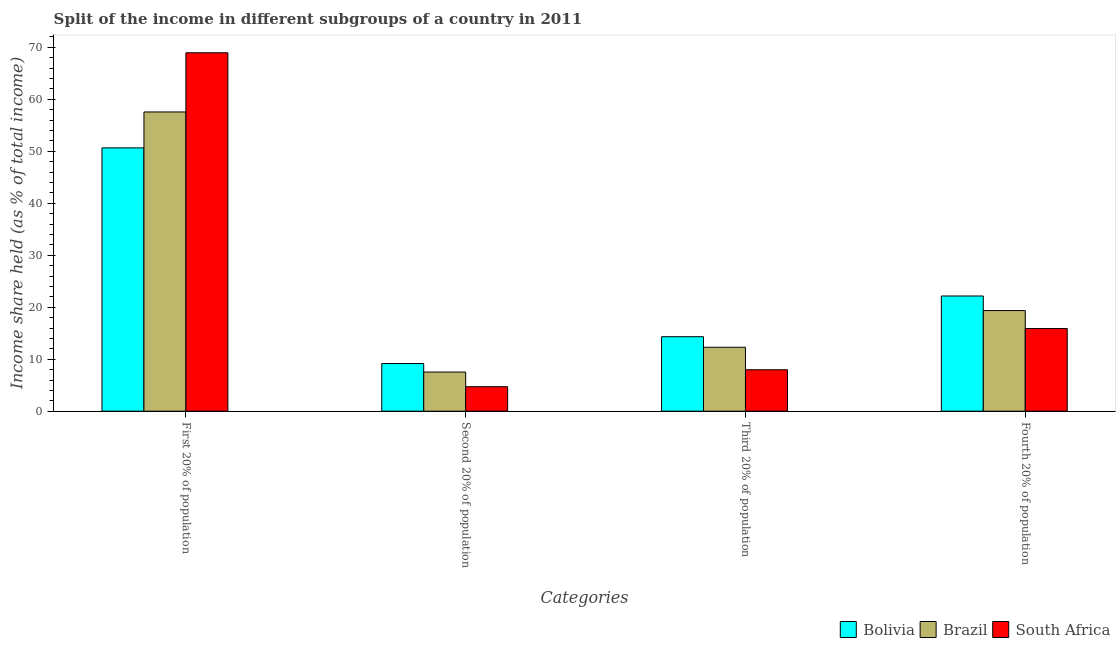How many groups of bars are there?
Offer a terse response. 4. Are the number of bars per tick equal to the number of legend labels?
Provide a short and direct response. Yes. Are the number of bars on each tick of the X-axis equal?
Your response must be concise. Yes. What is the label of the 4th group of bars from the left?
Your response must be concise. Fourth 20% of population. Across all countries, what is the maximum share of the income held by first 20% of the population?
Make the answer very short. 68.94. Across all countries, what is the minimum share of the income held by second 20% of the population?
Keep it short and to the point. 4.71. In which country was the share of the income held by third 20% of the population minimum?
Your answer should be very brief. South Africa. What is the total share of the income held by first 20% of the population in the graph?
Make the answer very short. 177.15. What is the difference between the share of the income held by third 20% of the population in Brazil and that in Bolivia?
Keep it short and to the point. -2.03. What is the difference between the share of the income held by first 20% of the population in South Africa and the share of the income held by third 20% of the population in Brazil?
Provide a short and direct response. 56.64. What is the average share of the income held by third 20% of the population per country?
Keep it short and to the point. 11.53. What is the difference between the share of the income held by first 20% of the population and share of the income held by third 20% of the population in South Africa?
Offer a terse response. 60.97. In how many countries, is the share of the income held by first 20% of the population greater than 14 %?
Provide a succinct answer. 3. What is the ratio of the share of the income held by third 20% of the population in Brazil to that in Bolivia?
Offer a terse response. 0.86. Is the difference between the share of the income held by second 20% of the population in Bolivia and South Africa greater than the difference between the share of the income held by third 20% of the population in Bolivia and South Africa?
Offer a very short reply. No. What is the difference between the highest and the second highest share of the income held by third 20% of the population?
Your response must be concise. 2.03. What is the difference between the highest and the lowest share of the income held by third 20% of the population?
Give a very brief answer. 6.36. In how many countries, is the share of the income held by first 20% of the population greater than the average share of the income held by first 20% of the population taken over all countries?
Keep it short and to the point. 1. Is the sum of the share of the income held by second 20% of the population in South Africa and Brazil greater than the maximum share of the income held by fourth 20% of the population across all countries?
Offer a very short reply. No. What does the 1st bar from the right in Fourth 20% of population represents?
Your response must be concise. South Africa. Is it the case that in every country, the sum of the share of the income held by first 20% of the population and share of the income held by second 20% of the population is greater than the share of the income held by third 20% of the population?
Provide a succinct answer. Yes. How many bars are there?
Your response must be concise. 12. How many countries are there in the graph?
Provide a short and direct response. 3. Does the graph contain grids?
Ensure brevity in your answer.  No. How many legend labels are there?
Make the answer very short. 3. What is the title of the graph?
Your answer should be very brief. Split of the income in different subgroups of a country in 2011. Does "Malta" appear as one of the legend labels in the graph?
Make the answer very short. No. What is the label or title of the X-axis?
Make the answer very short. Categories. What is the label or title of the Y-axis?
Your answer should be compact. Income share held (as % of total income). What is the Income share held (as % of total income) of Bolivia in First 20% of population?
Your answer should be compact. 50.65. What is the Income share held (as % of total income) of Brazil in First 20% of population?
Offer a terse response. 57.56. What is the Income share held (as % of total income) in South Africa in First 20% of population?
Offer a terse response. 68.94. What is the Income share held (as % of total income) in Bolivia in Second 20% of population?
Give a very brief answer. 9.17. What is the Income share held (as % of total income) in Brazil in Second 20% of population?
Your response must be concise. 7.53. What is the Income share held (as % of total income) in South Africa in Second 20% of population?
Ensure brevity in your answer.  4.71. What is the Income share held (as % of total income) in Bolivia in Third 20% of population?
Provide a short and direct response. 14.33. What is the Income share held (as % of total income) of South Africa in Third 20% of population?
Keep it short and to the point. 7.97. What is the Income share held (as % of total income) in Bolivia in Fourth 20% of population?
Keep it short and to the point. 22.16. What is the Income share held (as % of total income) of Brazil in Fourth 20% of population?
Provide a short and direct response. 19.36. Across all Categories, what is the maximum Income share held (as % of total income) of Bolivia?
Provide a succinct answer. 50.65. Across all Categories, what is the maximum Income share held (as % of total income) in Brazil?
Offer a terse response. 57.56. Across all Categories, what is the maximum Income share held (as % of total income) in South Africa?
Your answer should be compact. 68.94. Across all Categories, what is the minimum Income share held (as % of total income) of Bolivia?
Keep it short and to the point. 9.17. Across all Categories, what is the minimum Income share held (as % of total income) of Brazil?
Your response must be concise. 7.53. Across all Categories, what is the minimum Income share held (as % of total income) of South Africa?
Offer a terse response. 4.71. What is the total Income share held (as % of total income) in Bolivia in the graph?
Provide a succinct answer. 96.31. What is the total Income share held (as % of total income) of Brazil in the graph?
Your answer should be very brief. 96.75. What is the total Income share held (as % of total income) in South Africa in the graph?
Offer a terse response. 97.52. What is the difference between the Income share held (as % of total income) of Bolivia in First 20% of population and that in Second 20% of population?
Give a very brief answer. 41.48. What is the difference between the Income share held (as % of total income) of Brazil in First 20% of population and that in Second 20% of population?
Your answer should be very brief. 50.03. What is the difference between the Income share held (as % of total income) of South Africa in First 20% of population and that in Second 20% of population?
Your answer should be very brief. 64.23. What is the difference between the Income share held (as % of total income) of Bolivia in First 20% of population and that in Third 20% of population?
Your response must be concise. 36.32. What is the difference between the Income share held (as % of total income) in Brazil in First 20% of population and that in Third 20% of population?
Keep it short and to the point. 45.26. What is the difference between the Income share held (as % of total income) of South Africa in First 20% of population and that in Third 20% of population?
Provide a succinct answer. 60.97. What is the difference between the Income share held (as % of total income) in Bolivia in First 20% of population and that in Fourth 20% of population?
Keep it short and to the point. 28.49. What is the difference between the Income share held (as % of total income) in Brazil in First 20% of population and that in Fourth 20% of population?
Offer a very short reply. 38.2. What is the difference between the Income share held (as % of total income) in South Africa in First 20% of population and that in Fourth 20% of population?
Provide a short and direct response. 53.04. What is the difference between the Income share held (as % of total income) in Bolivia in Second 20% of population and that in Third 20% of population?
Your answer should be compact. -5.16. What is the difference between the Income share held (as % of total income) of Brazil in Second 20% of population and that in Third 20% of population?
Give a very brief answer. -4.77. What is the difference between the Income share held (as % of total income) in South Africa in Second 20% of population and that in Third 20% of population?
Make the answer very short. -3.26. What is the difference between the Income share held (as % of total income) of Bolivia in Second 20% of population and that in Fourth 20% of population?
Provide a short and direct response. -12.99. What is the difference between the Income share held (as % of total income) in Brazil in Second 20% of population and that in Fourth 20% of population?
Provide a succinct answer. -11.83. What is the difference between the Income share held (as % of total income) in South Africa in Second 20% of population and that in Fourth 20% of population?
Give a very brief answer. -11.19. What is the difference between the Income share held (as % of total income) of Bolivia in Third 20% of population and that in Fourth 20% of population?
Ensure brevity in your answer.  -7.83. What is the difference between the Income share held (as % of total income) in Brazil in Third 20% of population and that in Fourth 20% of population?
Provide a short and direct response. -7.06. What is the difference between the Income share held (as % of total income) in South Africa in Third 20% of population and that in Fourth 20% of population?
Provide a succinct answer. -7.93. What is the difference between the Income share held (as % of total income) in Bolivia in First 20% of population and the Income share held (as % of total income) in Brazil in Second 20% of population?
Your response must be concise. 43.12. What is the difference between the Income share held (as % of total income) of Bolivia in First 20% of population and the Income share held (as % of total income) of South Africa in Second 20% of population?
Your answer should be compact. 45.94. What is the difference between the Income share held (as % of total income) of Brazil in First 20% of population and the Income share held (as % of total income) of South Africa in Second 20% of population?
Provide a succinct answer. 52.85. What is the difference between the Income share held (as % of total income) of Bolivia in First 20% of population and the Income share held (as % of total income) of Brazil in Third 20% of population?
Give a very brief answer. 38.35. What is the difference between the Income share held (as % of total income) in Bolivia in First 20% of population and the Income share held (as % of total income) in South Africa in Third 20% of population?
Provide a short and direct response. 42.68. What is the difference between the Income share held (as % of total income) of Brazil in First 20% of population and the Income share held (as % of total income) of South Africa in Third 20% of population?
Offer a very short reply. 49.59. What is the difference between the Income share held (as % of total income) of Bolivia in First 20% of population and the Income share held (as % of total income) of Brazil in Fourth 20% of population?
Provide a short and direct response. 31.29. What is the difference between the Income share held (as % of total income) in Bolivia in First 20% of population and the Income share held (as % of total income) in South Africa in Fourth 20% of population?
Offer a terse response. 34.75. What is the difference between the Income share held (as % of total income) in Brazil in First 20% of population and the Income share held (as % of total income) in South Africa in Fourth 20% of population?
Your response must be concise. 41.66. What is the difference between the Income share held (as % of total income) of Bolivia in Second 20% of population and the Income share held (as % of total income) of Brazil in Third 20% of population?
Your answer should be very brief. -3.13. What is the difference between the Income share held (as % of total income) in Bolivia in Second 20% of population and the Income share held (as % of total income) in South Africa in Third 20% of population?
Your response must be concise. 1.2. What is the difference between the Income share held (as % of total income) in Brazil in Second 20% of population and the Income share held (as % of total income) in South Africa in Third 20% of population?
Offer a very short reply. -0.44. What is the difference between the Income share held (as % of total income) in Bolivia in Second 20% of population and the Income share held (as % of total income) in Brazil in Fourth 20% of population?
Your response must be concise. -10.19. What is the difference between the Income share held (as % of total income) in Bolivia in Second 20% of population and the Income share held (as % of total income) in South Africa in Fourth 20% of population?
Offer a terse response. -6.73. What is the difference between the Income share held (as % of total income) in Brazil in Second 20% of population and the Income share held (as % of total income) in South Africa in Fourth 20% of population?
Keep it short and to the point. -8.37. What is the difference between the Income share held (as % of total income) of Bolivia in Third 20% of population and the Income share held (as % of total income) of Brazil in Fourth 20% of population?
Make the answer very short. -5.03. What is the difference between the Income share held (as % of total income) in Bolivia in Third 20% of population and the Income share held (as % of total income) in South Africa in Fourth 20% of population?
Your answer should be very brief. -1.57. What is the difference between the Income share held (as % of total income) in Brazil in Third 20% of population and the Income share held (as % of total income) in South Africa in Fourth 20% of population?
Ensure brevity in your answer.  -3.6. What is the average Income share held (as % of total income) in Bolivia per Categories?
Your answer should be compact. 24.08. What is the average Income share held (as % of total income) of Brazil per Categories?
Offer a terse response. 24.19. What is the average Income share held (as % of total income) in South Africa per Categories?
Offer a terse response. 24.38. What is the difference between the Income share held (as % of total income) of Bolivia and Income share held (as % of total income) of Brazil in First 20% of population?
Your response must be concise. -6.91. What is the difference between the Income share held (as % of total income) of Bolivia and Income share held (as % of total income) of South Africa in First 20% of population?
Offer a terse response. -18.29. What is the difference between the Income share held (as % of total income) of Brazil and Income share held (as % of total income) of South Africa in First 20% of population?
Your response must be concise. -11.38. What is the difference between the Income share held (as % of total income) of Bolivia and Income share held (as % of total income) of Brazil in Second 20% of population?
Provide a short and direct response. 1.64. What is the difference between the Income share held (as % of total income) in Bolivia and Income share held (as % of total income) in South Africa in Second 20% of population?
Make the answer very short. 4.46. What is the difference between the Income share held (as % of total income) in Brazil and Income share held (as % of total income) in South Africa in Second 20% of population?
Provide a succinct answer. 2.82. What is the difference between the Income share held (as % of total income) in Bolivia and Income share held (as % of total income) in Brazil in Third 20% of population?
Your answer should be very brief. 2.03. What is the difference between the Income share held (as % of total income) in Bolivia and Income share held (as % of total income) in South Africa in Third 20% of population?
Ensure brevity in your answer.  6.36. What is the difference between the Income share held (as % of total income) in Brazil and Income share held (as % of total income) in South Africa in Third 20% of population?
Your answer should be very brief. 4.33. What is the difference between the Income share held (as % of total income) in Bolivia and Income share held (as % of total income) in South Africa in Fourth 20% of population?
Offer a very short reply. 6.26. What is the difference between the Income share held (as % of total income) in Brazil and Income share held (as % of total income) in South Africa in Fourth 20% of population?
Provide a short and direct response. 3.46. What is the ratio of the Income share held (as % of total income) in Bolivia in First 20% of population to that in Second 20% of population?
Keep it short and to the point. 5.52. What is the ratio of the Income share held (as % of total income) of Brazil in First 20% of population to that in Second 20% of population?
Offer a very short reply. 7.64. What is the ratio of the Income share held (as % of total income) in South Africa in First 20% of population to that in Second 20% of population?
Offer a terse response. 14.64. What is the ratio of the Income share held (as % of total income) in Bolivia in First 20% of population to that in Third 20% of population?
Your answer should be compact. 3.53. What is the ratio of the Income share held (as % of total income) in Brazil in First 20% of population to that in Third 20% of population?
Your answer should be very brief. 4.68. What is the ratio of the Income share held (as % of total income) of South Africa in First 20% of population to that in Third 20% of population?
Your answer should be very brief. 8.65. What is the ratio of the Income share held (as % of total income) of Bolivia in First 20% of population to that in Fourth 20% of population?
Your response must be concise. 2.29. What is the ratio of the Income share held (as % of total income) in Brazil in First 20% of population to that in Fourth 20% of population?
Make the answer very short. 2.97. What is the ratio of the Income share held (as % of total income) of South Africa in First 20% of population to that in Fourth 20% of population?
Give a very brief answer. 4.34. What is the ratio of the Income share held (as % of total income) of Bolivia in Second 20% of population to that in Third 20% of population?
Keep it short and to the point. 0.64. What is the ratio of the Income share held (as % of total income) of Brazil in Second 20% of population to that in Third 20% of population?
Provide a succinct answer. 0.61. What is the ratio of the Income share held (as % of total income) of South Africa in Second 20% of population to that in Third 20% of population?
Keep it short and to the point. 0.59. What is the ratio of the Income share held (as % of total income) in Bolivia in Second 20% of population to that in Fourth 20% of population?
Your answer should be compact. 0.41. What is the ratio of the Income share held (as % of total income) of Brazil in Second 20% of population to that in Fourth 20% of population?
Offer a terse response. 0.39. What is the ratio of the Income share held (as % of total income) in South Africa in Second 20% of population to that in Fourth 20% of population?
Make the answer very short. 0.3. What is the ratio of the Income share held (as % of total income) of Bolivia in Third 20% of population to that in Fourth 20% of population?
Provide a short and direct response. 0.65. What is the ratio of the Income share held (as % of total income) in Brazil in Third 20% of population to that in Fourth 20% of population?
Provide a succinct answer. 0.64. What is the ratio of the Income share held (as % of total income) of South Africa in Third 20% of population to that in Fourth 20% of population?
Provide a short and direct response. 0.5. What is the difference between the highest and the second highest Income share held (as % of total income) in Bolivia?
Offer a terse response. 28.49. What is the difference between the highest and the second highest Income share held (as % of total income) in Brazil?
Provide a short and direct response. 38.2. What is the difference between the highest and the second highest Income share held (as % of total income) of South Africa?
Your answer should be compact. 53.04. What is the difference between the highest and the lowest Income share held (as % of total income) of Bolivia?
Your answer should be compact. 41.48. What is the difference between the highest and the lowest Income share held (as % of total income) in Brazil?
Keep it short and to the point. 50.03. What is the difference between the highest and the lowest Income share held (as % of total income) in South Africa?
Give a very brief answer. 64.23. 